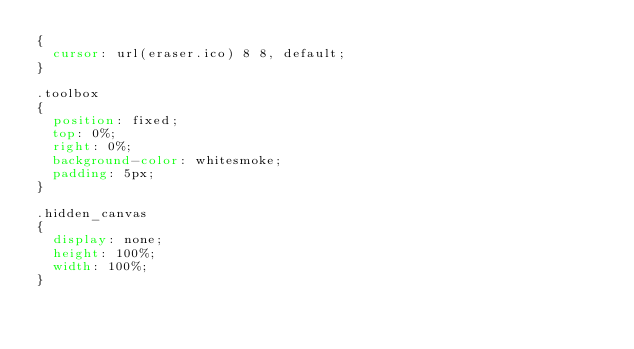Convert code to text. <code><loc_0><loc_0><loc_500><loc_500><_CSS_>{
	cursor: url(eraser.ico) 8 8, default;
}

.toolbox
{
	position: fixed;
	top: 0%;
	right: 0%;
	background-color: whitesmoke;
	padding: 5px;
}

.hidden_canvas
{
	display: none;
	height: 100%;
	width: 100%;
}</code> 